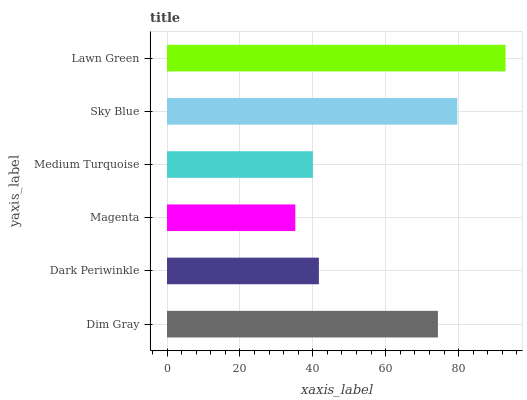Is Magenta the minimum?
Answer yes or no. Yes. Is Lawn Green the maximum?
Answer yes or no. Yes. Is Dark Periwinkle the minimum?
Answer yes or no. No. Is Dark Periwinkle the maximum?
Answer yes or no. No. Is Dim Gray greater than Dark Periwinkle?
Answer yes or no. Yes. Is Dark Periwinkle less than Dim Gray?
Answer yes or no. Yes. Is Dark Periwinkle greater than Dim Gray?
Answer yes or no. No. Is Dim Gray less than Dark Periwinkle?
Answer yes or no. No. Is Dim Gray the high median?
Answer yes or no. Yes. Is Dark Periwinkle the low median?
Answer yes or no. Yes. Is Lawn Green the high median?
Answer yes or no. No. Is Sky Blue the low median?
Answer yes or no. No. 